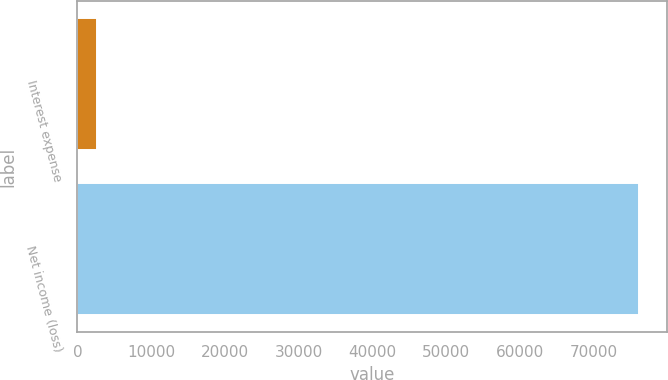<chart> <loc_0><loc_0><loc_500><loc_500><bar_chart><fcel>Interest expense<fcel>Net income (loss)<nl><fcel>2725<fcel>76168<nl></chart> 